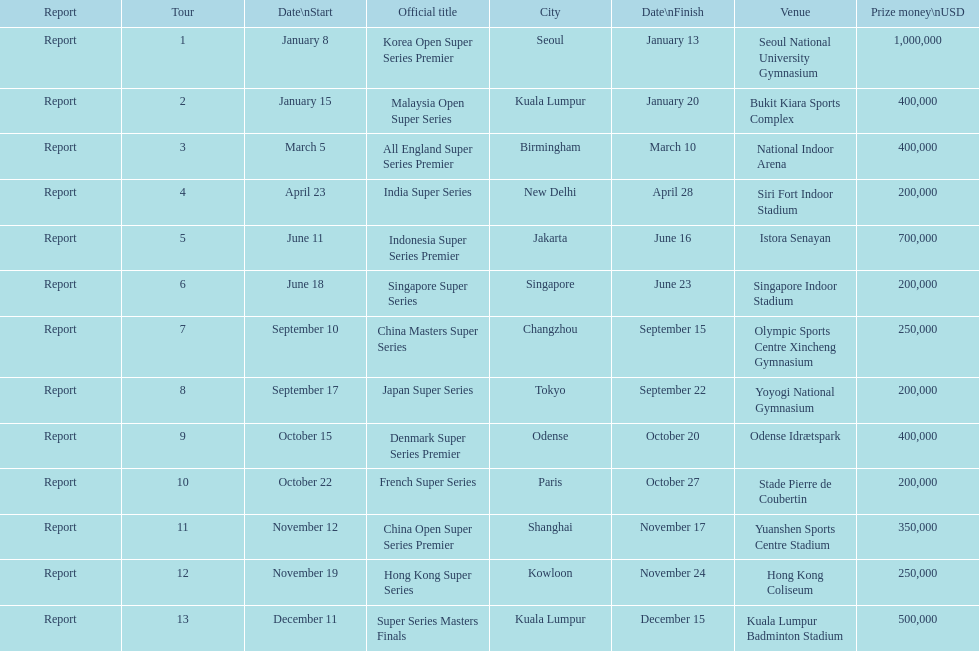Does the malaysia open super series pay more or less than french super series? More. 